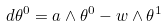Convert formula to latex. <formula><loc_0><loc_0><loc_500><loc_500>d \theta ^ { 0 } = a \wedge \theta ^ { 0 } - w \wedge \theta ^ { 1 }</formula> 